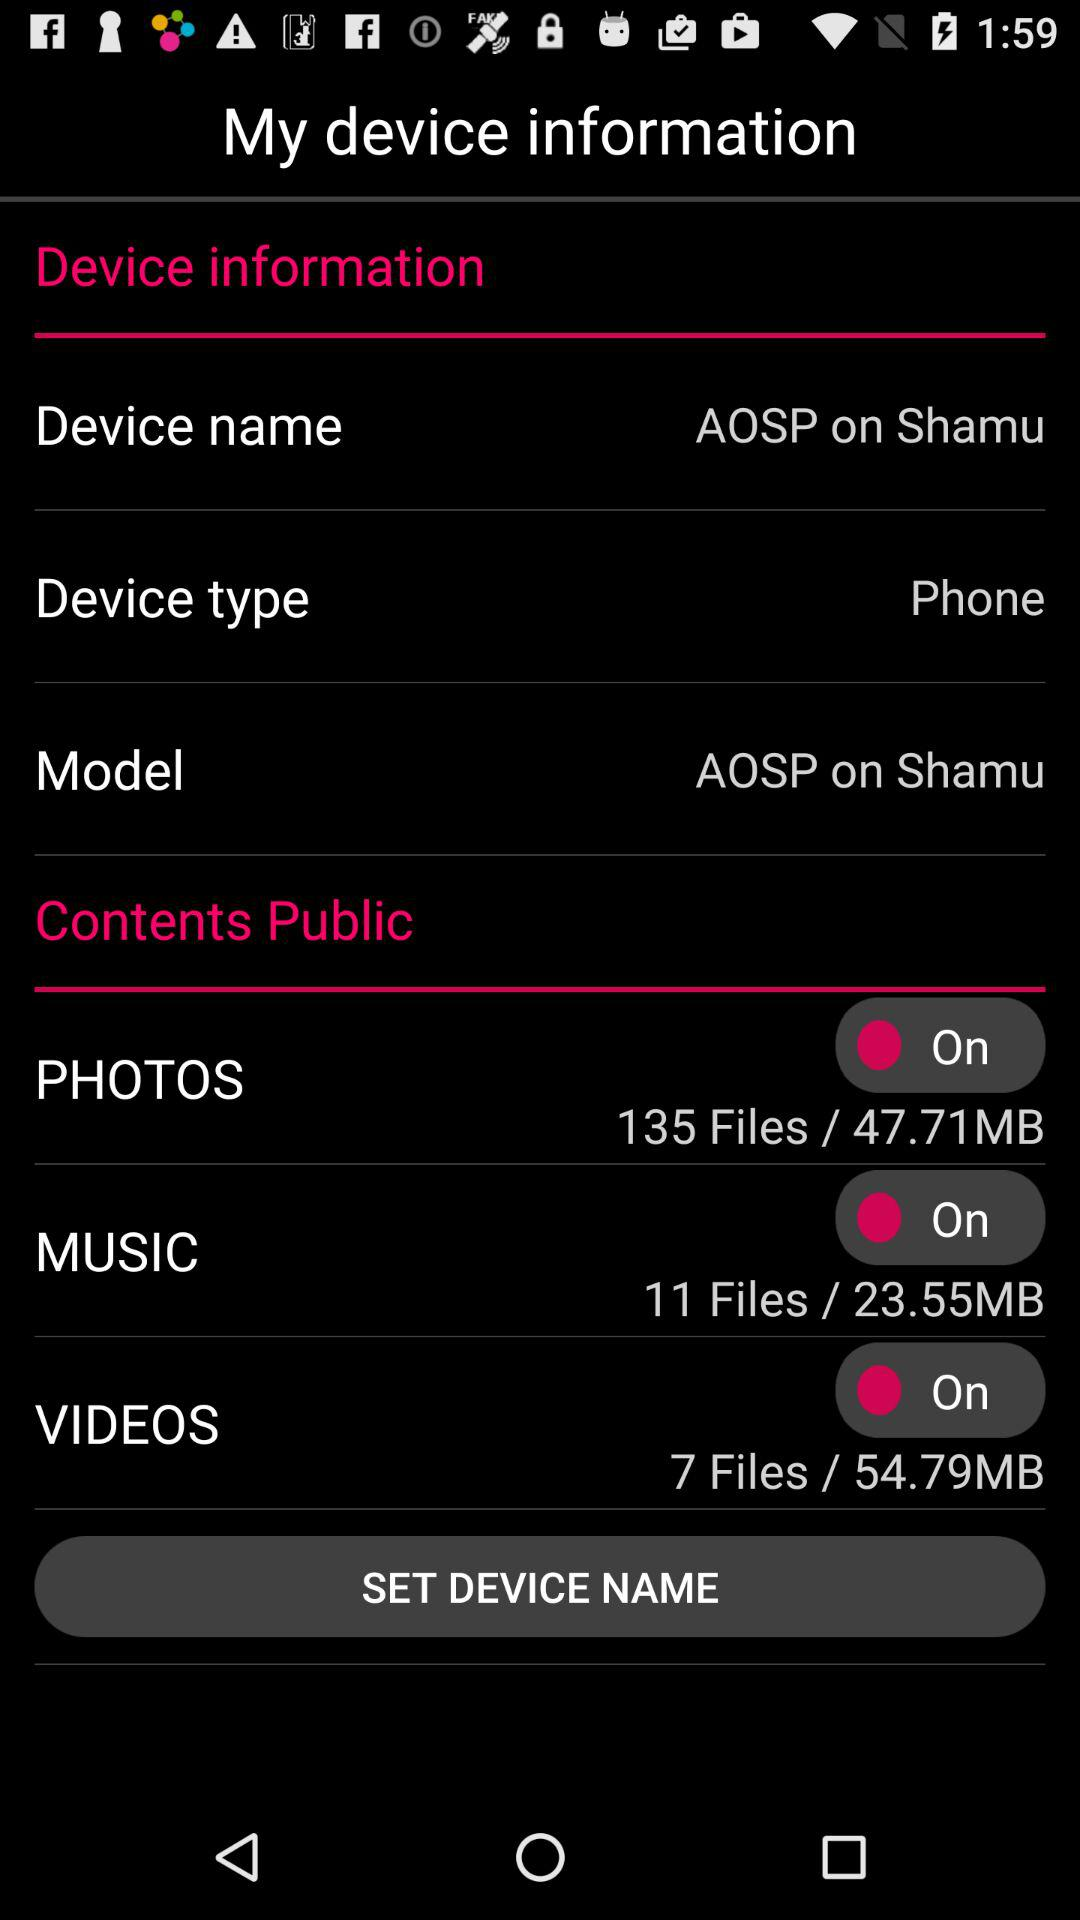What is the highest number of files? The highest number of files is 135. 